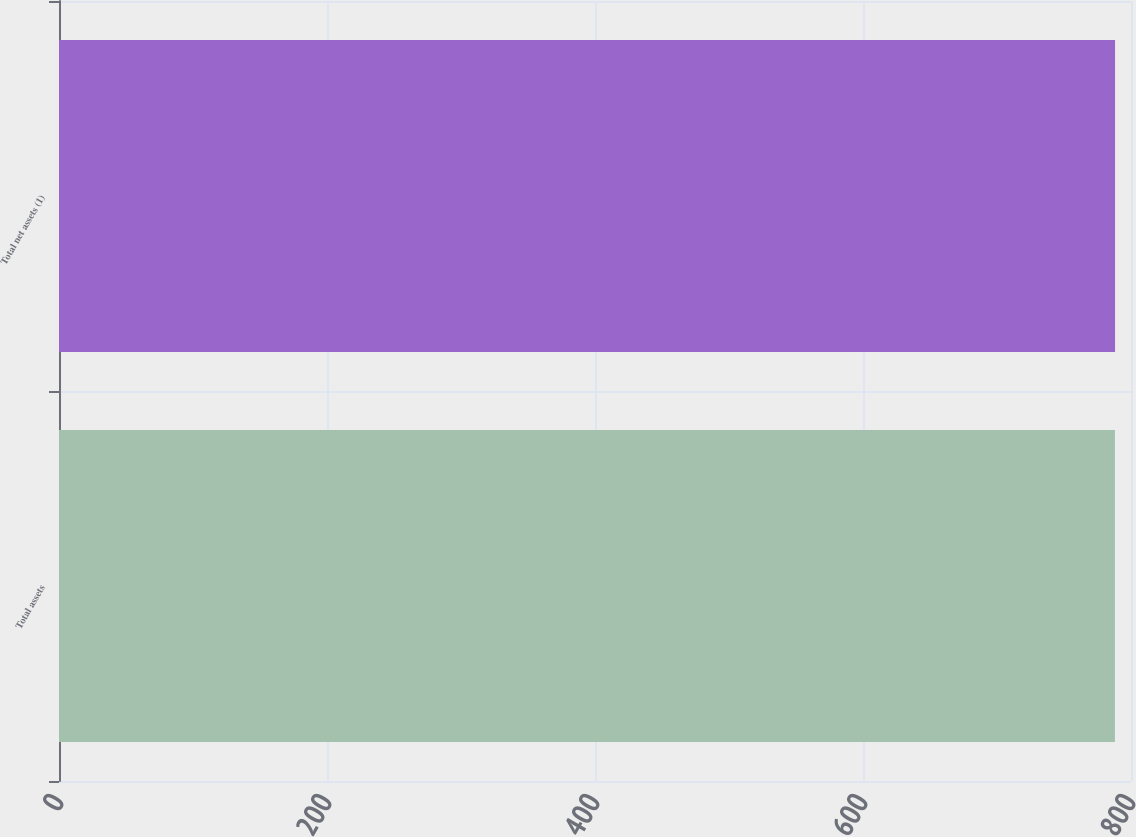<chart> <loc_0><loc_0><loc_500><loc_500><bar_chart><fcel>Total assets<fcel>Total net assets (1)<nl><fcel>788<fcel>788.1<nl></chart> 